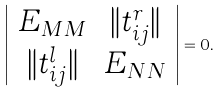Convert formula to latex. <formula><loc_0><loc_0><loc_500><loc_500>\left | \begin{array} { c c } E _ { M M } & \| t _ { i j } ^ { r } \| \\ \| t _ { i j } ^ { l } \| & E _ { N N } \end{array} \right | = 0 .</formula> 